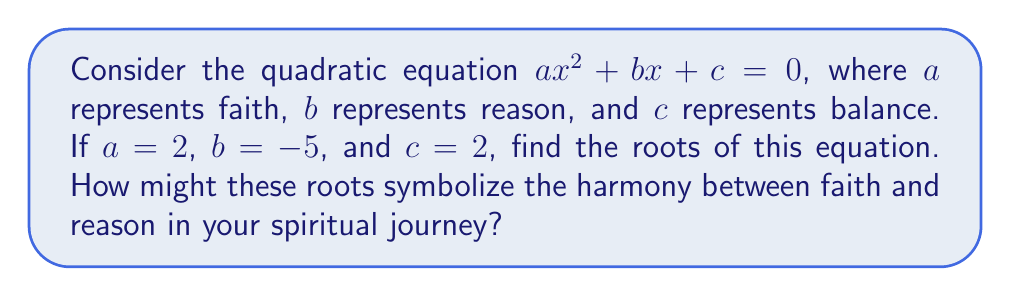Can you solve this math problem? To find the roots of the quadratic equation $2x^2 - 5x + 2 = 0$, we'll use the quadratic formula:

$$x = \frac{-b \pm \sqrt{b^2 - 4ac}}{2a}$$

Step 1: Identify the coefficients
$a = 2$, $b = -5$, and $c = 2$

Step 2: Substitute the values into the quadratic formula
$$x = \frac{-(-5) \pm \sqrt{(-5)^2 - 4(2)(2)}}{2(2)}$$

Step 3: Simplify
$$x = \frac{5 \pm \sqrt{25 - 16}}{4} = \frac{5 \pm \sqrt{9}}{4} = \frac{5 \pm 3}{4}$$

Step 4: Calculate the two roots
$$x_1 = \frac{5 + 3}{4} = \frac{8}{4} = 2$$
$$x_2 = \frac{5 - 3}{4} = \frac{2}{4} = \frac{1}{2}$$

The roots 2 and 1/2 symbolize the balance between faith and reason. The larger root (2) may represent the strength of faith, while the smaller root (1/2) could symbolize the humility of reason. Their product (2 × 1/2 = 1) equals 1, suggesting a perfect harmony between faith and reason in one's spiritual journey.
Answer: $x_1 = 2$, $x_2 = \frac{1}{2}$ 